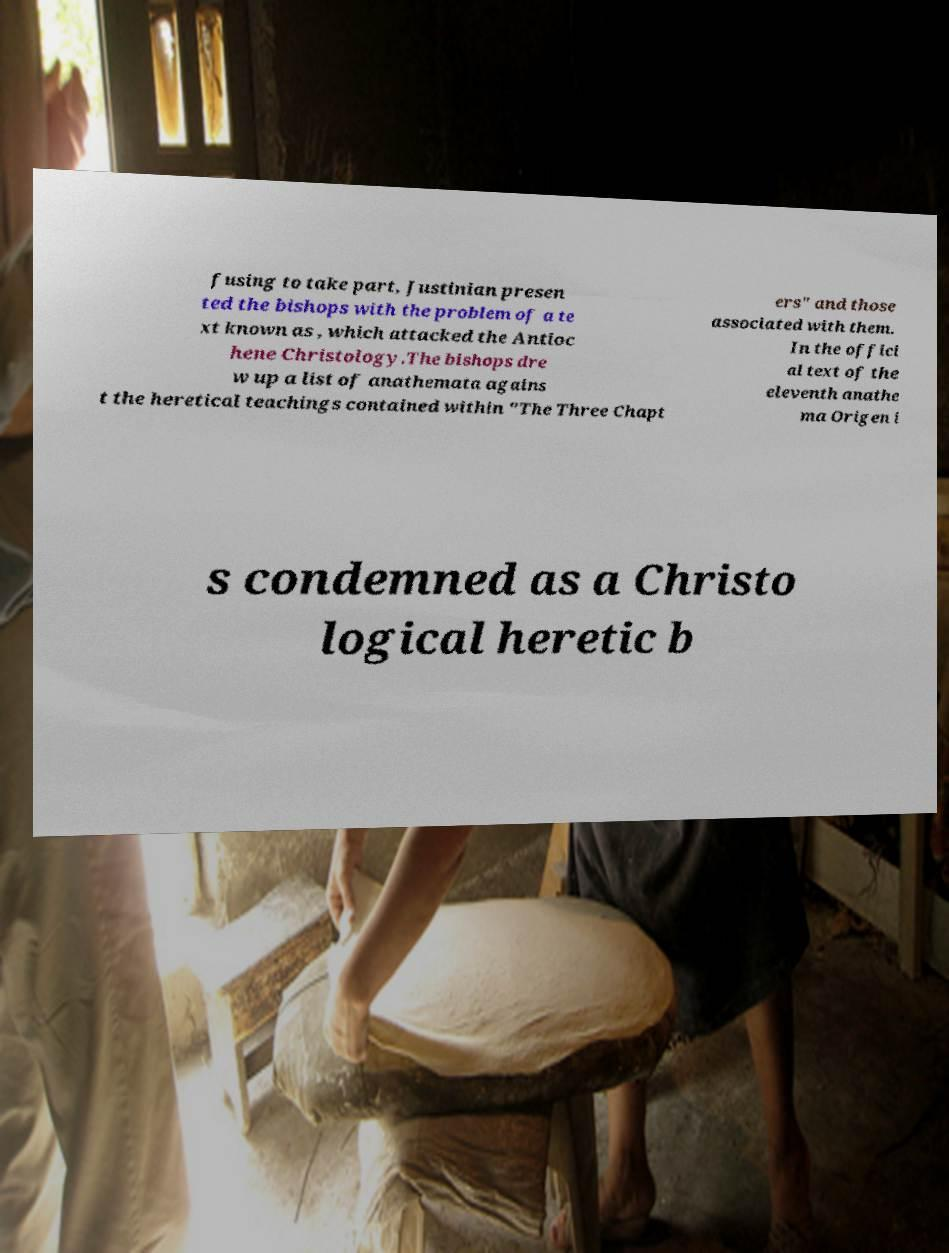There's text embedded in this image that I need extracted. Can you transcribe it verbatim? fusing to take part, Justinian presen ted the bishops with the problem of a te xt known as , which attacked the Antioc hene Christology.The bishops dre w up a list of anathemata agains t the heretical teachings contained within "The Three Chapt ers" and those associated with them. In the offici al text of the eleventh anathe ma Origen i s condemned as a Christo logical heretic b 